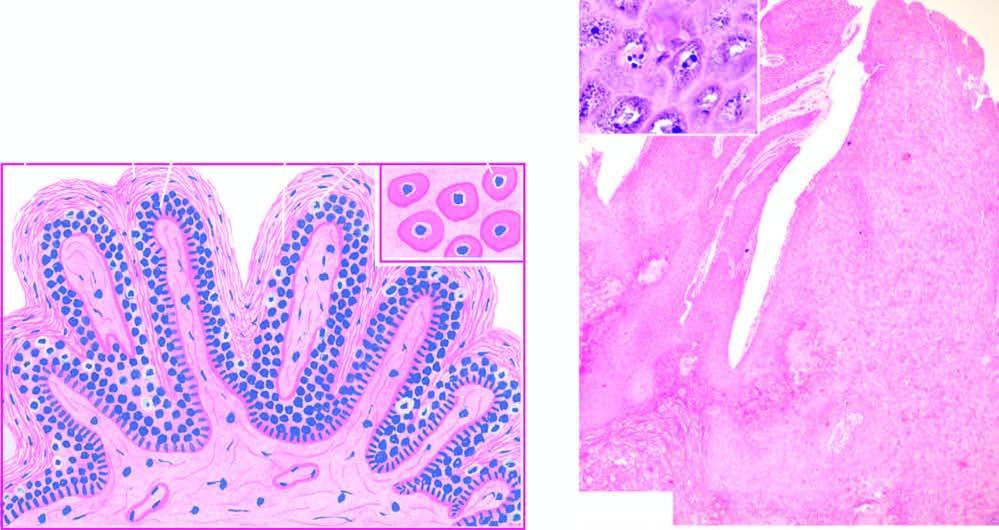what are found in the upper stratum malpighii?
Answer the question using a single word or phrase. Foci of vacuolated cells 